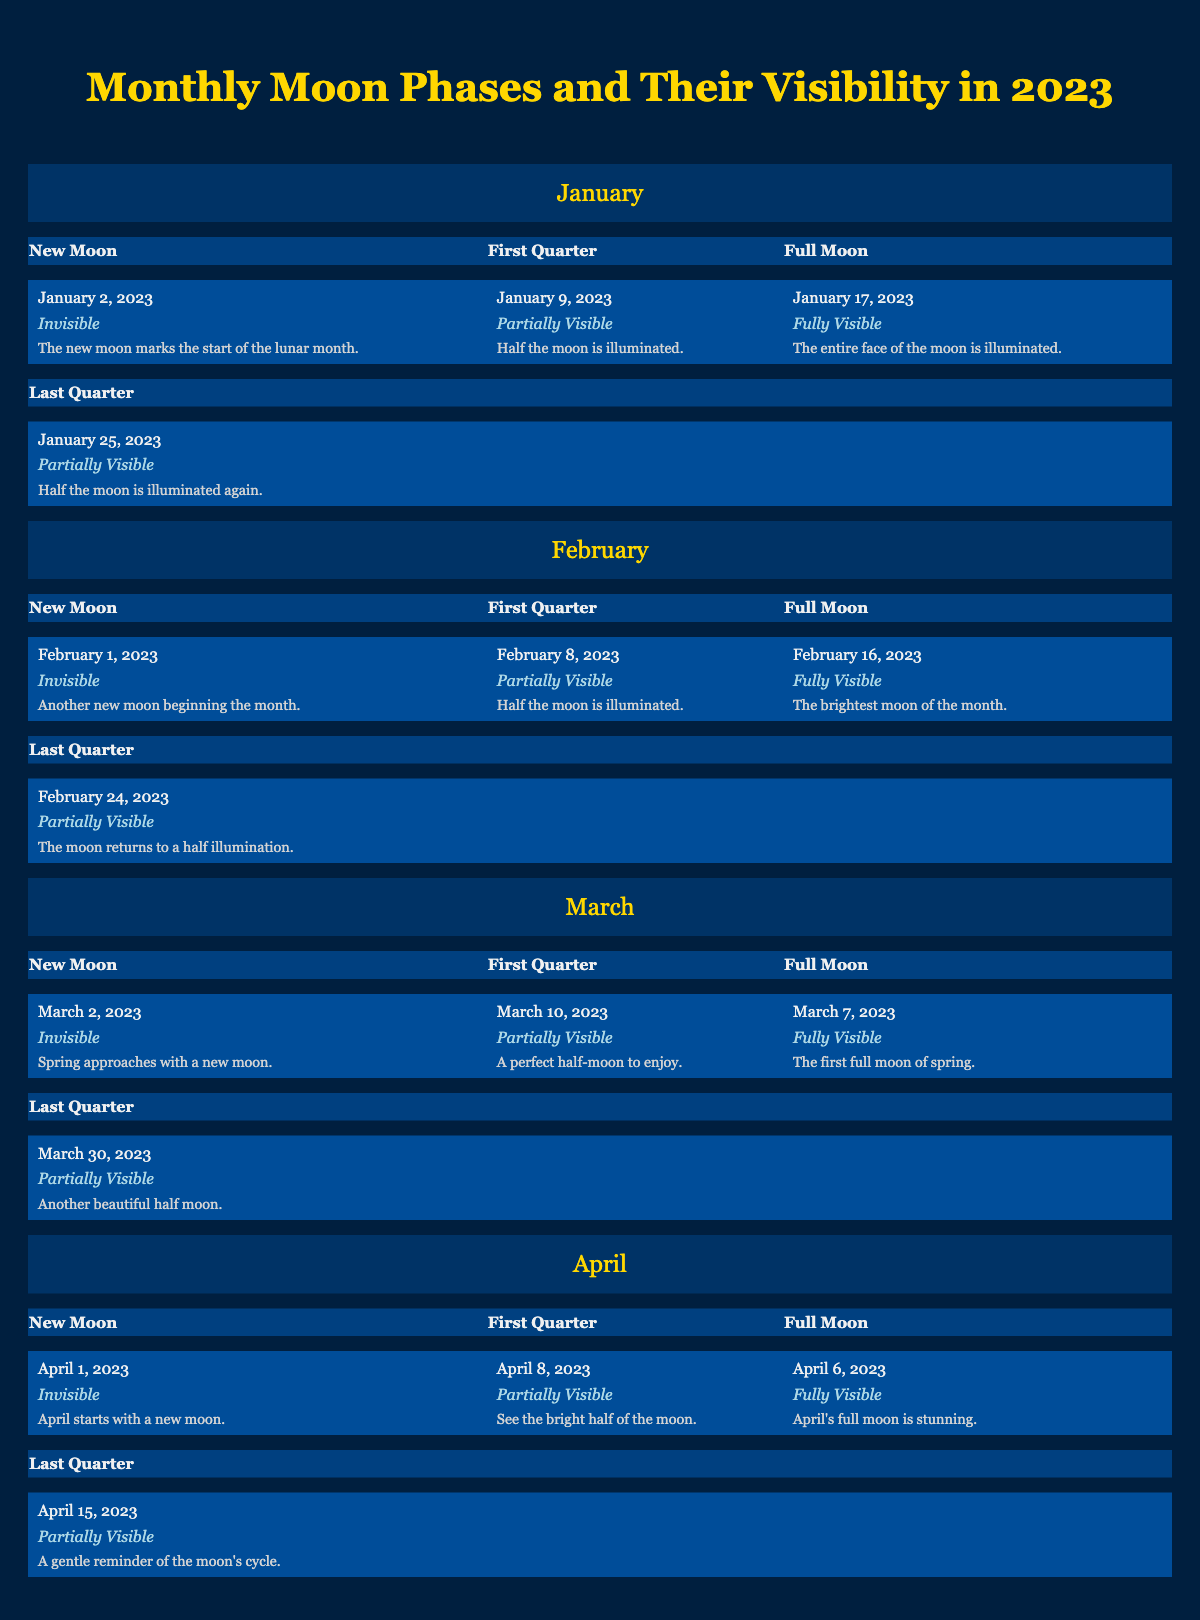What day does the Full Moon occur in January 2023? The Full Moon in January 2023 occurs on January 17, 2023. This information can be directly retrieved from the January section of the table.
Answer: January 17, 2023 What is the visibility of the New Moon in February 2023? The New Moon in February 2023 is characterized as "Invisible." This detail is found in the February section of the table under New Moon.
Answer: Invisible How many Full Moons are there in the first four months of 2023? The Full Moons occur in January, February, March, and April 2023, totaling four months with one Full Moon each. This information can be confirmed by counting the Full Moon entries in each of those months in the table.
Answer: 4 During which month is the Full Moon described as "the brightest moon of the month"? The Full Moon described as "the brightest moon of the month" occurs in February 2023, specifically on February 16, 2023. This is stated in the February section.
Answer: February Is there a New Moon in April 2023? Yes, there is a New Moon in April 2023, occurring on April 1, 2023. This information is confirmed by looking at the April section in the table, under New Moon.
Answer: Yes What is the date of the First Quarter in March 2023 and what is its visibility? The First Quarter in March 2023 occurs on March 10, 2023, and its visibility is "Partially Visible." This can be found by checking the March section of the table under First Quarter.
Answer: March 10, 2023, Partially Visible What is the average visibility type among all Full Moons in the first four months? All Full Moons in January, February, March, and April are "Fully Visible" on their respective dates. Since they are all the same, the average visibility can be stated as "Fully Visible." This involves evaluating each Full Moon's visibility in the table to reach this conclusion.
Answer: Fully Visible When is the last quarter moon in January 2023, and how does its visibility compare to that of the First Quarter in January? The Last Quarter Moon in January 2023 falls on January 25, 2023, and it is "Partially Visible." In comparison, the First Quarter in January is also "Partially Visible." This information is retrieved from both the January Last Quarter and First Quarter sections in the table, showing they have the same visibility.
Answer: January 25, 2023, Partially Visible; same as First Quarter 